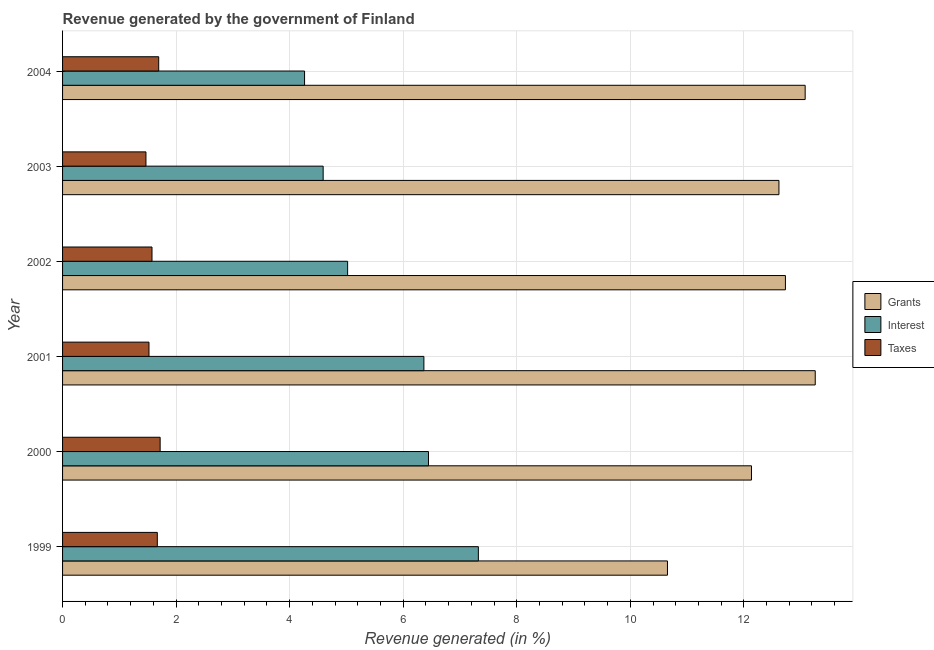How many groups of bars are there?
Make the answer very short. 6. How many bars are there on the 4th tick from the top?
Your response must be concise. 3. How many bars are there on the 1st tick from the bottom?
Provide a short and direct response. 3. In how many cases, is the number of bars for a given year not equal to the number of legend labels?
Ensure brevity in your answer.  0. What is the percentage of revenue generated by interest in 2003?
Ensure brevity in your answer.  4.59. Across all years, what is the maximum percentage of revenue generated by grants?
Keep it short and to the point. 13.26. Across all years, what is the minimum percentage of revenue generated by grants?
Your response must be concise. 10.65. In which year was the percentage of revenue generated by interest maximum?
Your response must be concise. 1999. What is the total percentage of revenue generated by interest in the graph?
Give a very brief answer. 34.01. What is the difference between the percentage of revenue generated by taxes in 2003 and that in 2004?
Your answer should be very brief. -0.23. What is the difference between the percentage of revenue generated by grants in 2001 and the percentage of revenue generated by interest in 2003?
Provide a succinct answer. 8.67. What is the average percentage of revenue generated by taxes per year?
Make the answer very short. 1.61. In the year 2003, what is the difference between the percentage of revenue generated by grants and percentage of revenue generated by taxes?
Provide a short and direct response. 11.15. In how many years, is the percentage of revenue generated by taxes greater than 10.4 %?
Your response must be concise. 0. What is the ratio of the percentage of revenue generated by interest in 2002 to that in 2004?
Your answer should be very brief. 1.18. Is the percentage of revenue generated by grants in 2000 less than that in 2001?
Your response must be concise. Yes. Is the difference between the percentage of revenue generated by taxes in 2000 and 2004 greater than the difference between the percentage of revenue generated by grants in 2000 and 2004?
Provide a short and direct response. Yes. What is the difference between the highest and the second highest percentage of revenue generated by interest?
Make the answer very short. 0.88. In how many years, is the percentage of revenue generated by interest greater than the average percentage of revenue generated by interest taken over all years?
Give a very brief answer. 3. What does the 1st bar from the top in 2000 represents?
Keep it short and to the point. Taxes. What does the 1st bar from the bottom in 2001 represents?
Give a very brief answer. Grants. How many years are there in the graph?
Your response must be concise. 6. Are the values on the major ticks of X-axis written in scientific E-notation?
Provide a succinct answer. No. Does the graph contain grids?
Provide a succinct answer. Yes. Where does the legend appear in the graph?
Ensure brevity in your answer.  Center right. How many legend labels are there?
Offer a very short reply. 3. What is the title of the graph?
Offer a terse response. Revenue generated by the government of Finland. What is the label or title of the X-axis?
Offer a very short reply. Revenue generated (in %). What is the label or title of the Y-axis?
Offer a terse response. Year. What is the Revenue generated (in %) of Grants in 1999?
Ensure brevity in your answer.  10.65. What is the Revenue generated (in %) in Interest in 1999?
Your response must be concise. 7.32. What is the Revenue generated (in %) of Taxes in 1999?
Ensure brevity in your answer.  1.67. What is the Revenue generated (in %) of Grants in 2000?
Your answer should be compact. 12.13. What is the Revenue generated (in %) in Interest in 2000?
Offer a terse response. 6.45. What is the Revenue generated (in %) in Taxes in 2000?
Offer a terse response. 1.72. What is the Revenue generated (in %) in Grants in 2001?
Offer a very short reply. 13.26. What is the Revenue generated (in %) of Interest in 2001?
Offer a very short reply. 6.36. What is the Revenue generated (in %) of Taxes in 2001?
Give a very brief answer. 1.52. What is the Revenue generated (in %) in Grants in 2002?
Provide a short and direct response. 12.73. What is the Revenue generated (in %) of Interest in 2002?
Your answer should be very brief. 5.02. What is the Revenue generated (in %) in Taxes in 2002?
Your answer should be compact. 1.58. What is the Revenue generated (in %) of Grants in 2003?
Make the answer very short. 12.62. What is the Revenue generated (in %) of Interest in 2003?
Give a very brief answer. 4.59. What is the Revenue generated (in %) of Taxes in 2003?
Offer a terse response. 1.47. What is the Revenue generated (in %) in Grants in 2004?
Provide a succinct answer. 13.08. What is the Revenue generated (in %) in Interest in 2004?
Your response must be concise. 4.26. What is the Revenue generated (in %) in Taxes in 2004?
Your response must be concise. 1.69. Across all years, what is the maximum Revenue generated (in %) in Grants?
Give a very brief answer. 13.26. Across all years, what is the maximum Revenue generated (in %) of Interest?
Offer a very short reply. 7.32. Across all years, what is the maximum Revenue generated (in %) in Taxes?
Your response must be concise. 1.72. Across all years, what is the minimum Revenue generated (in %) of Grants?
Ensure brevity in your answer.  10.65. Across all years, what is the minimum Revenue generated (in %) of Interest?
Provide a short and direct response. 4.26. Across all years, what is the minimum Revenue generated (in %) in Taxes?
Offer a very short reply. 1.47. What is the total Revenue generated (in %) in Grants in the graph?
Your answer should be compact. 74.48. What is the total Revenue generated (in %) of Interest in the graph?
Keep it short and to the point. 34.01. What is the total Revenue generated (in %) in Taxes in the graph?
Provide a short and direct response. 9.65. What is the difference between the Revenue generated (in %) in Grants in 1999 and that in 2000?
Offer a terse response. -1.48. What is the difference between the Revenue generated (in %) in Interest in 1999 and that in 2000?
Make the answer very short. 0.88. What is the difference between the Revenue generated (in %) of Taxes in 1999 and that in 2000?
Your answer should be compact. -0.05. What is the difference between the Revenue generated (in %) of Grants in 1999 and that in 2001?
Ensure brevity in your answer.  -2.6. What is the difference between the Revenue generated (in %) of Interest in 1999 and that in 2001?
Ensure brevity in your answer.  0.96. What is the difference between the Revenue generated (in %) in Taxes in 1999 and that in 2001?
Provide a succinct answer. 0.15. What is the difference between the Revenue generated (in %) of Grants in 1999 and that in 2002?
Keep it short and to the point. -2.08. What is the difference between the Revenue generated (in %) of Interest in 1999 and that in 2002?
Offer a very short reply. 2.3. What is the difference between the Revenue generated (in %) of Taxes in 1999 and that in 2002?
Offer a very short reply. 0.09. What is the difference between the Revenue generated (in %) in Grants in 1999 and that in 2003?
Offer a very short reply. -1.96. What is the difference between the Revenue generated (in %) in Interest in 1999 and that in 2003?
Your response must be concise. 2.73. What is the difference between the Revenue generated (in %) in Taxes in 1999 and that in 2003?
Provide a short and direct response. 0.2. What is the difference between the Revenue generated (in %) in Grants in 1999 and that in 2004?
Your answer should be very brief. -2.43. What is the difference between the Revenue generated (in %) of Interest in 1999 and that in 2004?
Your answer should be compact. 3.06. What is the difference between the Revenue generated (in %) in Taxes in 1999 and that in 2004?
Your response must be concise. -0.02. What is the difference between the Revenue generated (in %) of Grants in 2000 and that in 2001?
Keep it short and to the point. -1.12. What is the difference between the Revenue generated (in %) of Interest in 2000 and that in 2001?
Keep it short and to the point. 0.08. What is the difference between the Revenue generated (in %) of Taxes in 2000 and that in 2001?
Offer a very short reply. 0.2. What is the difference between the Revenue generated (in %) of Grants in 2000 and that in 2002?
Ensure brevity in your answer.  -0.6. What is the difference between the Revenue generated (in %) in Interest in 2000 and that in 2002?
Ensure brevity in your answer.  1.42. What is the difference between the Revenue generated (in %) in Taxes in 2000 and that in 2002?
Give a very brief answer. 0.14. What is the difference between the Revenue generated (in %) of Grants in 2000 and that in 2003?
Ensure brevity in your answer.  -0.48. What is the difference between the Revenue generated (in %) of Interest in 2000 and that in 2003?
Your answer should be compact. 1.86. What is the difference between the Revenue generated (in %) in Taxes in 2000 and that in 2003?
Your answer should be very brief. 0.25. What is the difference between the Revenue generated (in %) of Grants in 2000 and that in 2004?
Your response must be concise. -0.95. What is the difference between the Revenue generated (in %) in Interest in 2000 and that in 2004?
Offer a terse response. 2.18. What is the difference between the Revenue generated (in %) in Taxes in 2000 and that in 2004?
Provide a succinct answer. 0.03. What is the difference between the Revenue generated (in %) in Grants in 2001 and that in 2002?
Offer a terse response. 0.53. What is the difference between the Revenue generated (in %) of Interest in 2001 and that in 2002?
Ensure brevity in your answer.  1.34. What is the difference between the Revenue generated (in %) in Taxes in 2001 and that in 2002?
Keep it short and to the point. -0.05. What is the difference between the Revenue generated (in %) in Grants in 2001 and that in 2003?
Your answer should be compact. 0.64. What is the difference between the Revenue generated (in %) of Interest in 2001 and that in 2003?
Offer a terse response. 1.77. What is the difference between the Revenue generated (in %) of Taxes in 2001 and that in 2003?
Provide a succinct answer. 0.05. What is the difference between the Revenue generated (in %) in Grants in 2001 and that in 2004?
Make the answer very short. 0.18. What is the difference between the Revenue generated (in %) in Interest in 2001 and that in 2004?
Your response must be concise. 2.1. What is the difference between the Revenue generated (in %) of Taxes in 2001 and that in 2004?
Provide a short and direct response. -0.17. What is the difference between the Revenue generated (in %) in Grants in 2002 and that in 2003?
Your answer should be very brief. 0.11. What is the difference between the Revenue generated (in %) in Interest in 2002 and that in 2003?
Keep it short and to the point. 0.43. What is the difference between the Revenue generated (in %) in Taxes in 2002 and that in 2003?
Give a very brief answer. 0.11. What is the difference between the Revenue generated (in %) in Grants in 2002 and that in 2004?
Offer a terse response. -0.35. What is the difference between the Revenue generated (in %) in Interest in 2002 and that in 2004?
Your response must be concise. 0.76. What is the difference between the Revenue generated (in %) in Taxes in 2002 and that in 2004?
Provide a succinct answer. -0.12. What is the difference between the Revenue generated (in %) in Grants in 2003 and that in 2004?
Your answer should be compact. -0.46. What is the difference between the Revenue generated (in %) of Interest in 2003 and that in 2004?
Offer a terse response. 0.33. What is the difference between the Revenue generated (in %) of Taxes in 2003 and that in 2004?
Keep it short and to the point. -0.22. What is the difference between the Revenue generated (in %) of Grants in 1999 and the Revenue generated (in %) of Interest in 2000?
Your answer should be very brief. 4.21. What is the difference between the Revenue generated (in %) of Grants in 1999 and the Revenue generated (in %) of Taxes in 2000?
Keep it short and to the point. 8.94. What is the difference between the Revenue generated (in %) of Interest in 1999 and the Revenue generated (in %) of Taxes in 2000?
Offer a terse response. 5.61. What is the difference between the Revenue generated (in %) in Grants in 1999 and the Revenue generated (in %) in Interest in 2001?
Offer a terse response. 4.29. What is the difference between the Revenue generated (in %) in Grants in 1999 and the Revenue generated (in %) in Taxes in 2001?
Offer a terse response. 9.13. What is the difference between the Revenue generated (in %) of Interest in 1999 and the Revenue generated (in %) of Taxes in 2001?
Offer a terse response. 5.8. What is the difference between the Revenue generated (in %) in Grants in 1999 and the Revenue generated (in %) in Interest in 2002?
Offer a very short reply. 5.63. What is the difference between the Revenue generated (in %) of Grants in 1999 and the Revenue generated (in %) of Taxes in 2002?
Ensure brevity in your answer.  9.08. What is the difference between the Revenue generated (in %) of Interest in 1999 and the Revenue generated (in %) of Taxes in 2002?
Keep it short and to the point. 5.75. What is the difference between the Revenue generated (in %) in Grants in 1999 and the Revenue generated (in %) in Interest in 2003?
Offer a very short reply. 6.06. What is the difference between the Revenue generated (in %) in Grants in 1999 and the Revenue generated (in %) in Taxes in 2003?
Your answer should be very brief. 9.19. What is the difference between the Revenue generated (in %) of Interest in 1999 and the Revenue generated (in %) of Taxes in 2003?
Ensure brevity in your answer.  5.86. What is the difference between the Revenue generated (in %) of Grants in 1999 and the Revenue generated (in %) of Interest in 2004?
Offer a terse response. 6.39. What is the difference between the Revenue generated (in %) of Grants in 1999 and the Revenue generated (in %) of Taxes in 2004?
Ensure brevity in your answer.  8.96. What is the difference between the Revenue generated (in %) in Interest in 1999 and the Revenue generated (in %) in Taxes in 2004?
Provide a short and direct response. 5.63. What is the difference between the Revenue generated (in %) in Grants in 2000 and the Revenue generated (in %) in Interest in 2001?
Offer a terse response. 5.77. What is the difference between the Revenue generated (in %) in Grants in 2000 and the Revenue generated (in %) in Taxes in 2001?
Provide a short and direct response. 10.61. What is the difference between the Revenue generated (in %) in Interest in 2000 and the Revenue generated (in %) in Taxes in 2001?
Keep it short and to the point. 4.92. What is the difference between the Revenue generated (in %) in Grants in 2000 and the Revenue generated (in %) in Interest in 2002?
Provide a succinct answer. 7.11. What is the difference between the Revenue generated (in %) in Grants in 2000 and the Revenue generated (in %) in Taxes in 2002?
Your response must be concise. 10.56. What is the difference between the Revenue generated (in %) of Interest in 2000 and the Revenue generated (in %) of Taxes in 2002?
Your answer should be compact. 4.87. What is the difference between the Revenue generated (in %) in Grants in 2000 and the Revenue generated (in %) in Interest in 2003?
Your answer should be compact. 7.54. What is the difference between the Revenue generated (in %) of Grants in 2000 and the Revenue generated (in %) of Taxes in 2003?
Your answer should be compact. 10.67. What is the difference between the Revenue generated (in %) of Interest in 2000 and the Revenue generated (in %) of Taxes in 2003?
Your answer should be very brief. 4.98. What is the difference between the Revenue generated (in %) of Grants in 2000 and the Revenue generated (in %) of Interest in 2004?
Keep it short and to the point. 7.87. What is the difference between the Revenue generated (in %) in Grants in 2000 and the Revenue generated (in %) in Taxes in 2004?
Your answer should be very brief. 10.44. What is the difference between the Revenue generated (in %) in Interest in 2000 and the Revenue generated (in %) in Taxes in 2004?
Provide a short and direct response. 4.75. What is the difference between the Revenue generated (in %) in Grants in 2001 and the Revenue generated (in %) in Interest in 2002?
Offer a terse response. 8.24. What is the difference between the Revenue generated (in %) in Grants in 2001 and the Revenue generated (in %) in Taxes in 2002?
Keep it short and to the point. 11.68. What is the difference between the Revenue generated (in %) in Interest in 2001 and the Revenue generated (in %) in Taxes in 2002?
Your answer should be compact. 4.79. What is the difference between the Revenue generated (in %) of Grants in 2001 and the Revenue generated (in %) of Interest in 2003?
Keep it short and to the point. 8.67. What is the difference between the Revenue generated (in %) of Grants in 2001 and the Revenue generated (in %) of Taxes in 2003?
Offer a very short reply. 11.79. What is the difference between the Revenue generated (in %) in Interest in 2001 and the Revenue generated (in %) in Taxes in 2003?
Your response must be concise. 4.9. What is the difference between the Revenue generated (in %) of Grants in 2001 and the Revenue generated (in %) of Interest in 2004?
Offer a terse response. 9. What is the difference between the Revenue generated (in %) in Grants in 2001 and the Revenue generated (in %) in Taxes in 2004?
Make the answer very short. 11.56. What is the difference between the Revenue generated (in %) of Interest in 2001 and the Revenue generated (in %) of Taxes in 2004?
Provide a short and direct response. 4.67. What is the difference between the Revenue generated (in %) in Grants in 2002 and the Revenue generated (in %) in Interest in 2003?
Ensure brevity in your answer.  8.14. What is the difference between the Revenue generated (in %) of Grants in 2002 and the Revenue generated (in %) of Taxes in 2003?
Offer a terse response. 11.26. What is the difference between the Revenue generated (in %) of Interest in 2002 and the Revenue generated (in %) of Taxes in 2003?
Your response must be concise. 3.55. What is the difference between the Revenue generated (in %) of Grants in 2002 and the Revenue generated (in %) of Interest in 2004?
Your answer should be compact. 8.47. What is the difference between the Revenue generated (in %) of Grants in 2002 and the Revenue generated (in %) of Taxes in 2004?
Offer a terse response. 11.04. What is the difference between the Revenue generated (in %) of Interest in 2002 and the Revenue generated (in %) of Taxes in 2004?
Keep it short and to the point. 3.33. What is the difference between the Revenue generated (in %) of Grants in 2003 and the Revenue generated (in %) of Interest in 2004?
Your response must be concise. 8.36. What is the difference between the Revenue generated (in %) of Grants in 2003 and the Revenue generated (in %) of Taxes in 2004?
Make the answer very short. 10.93. What is the difference between the Revenue generated (in %) of Interest in 2003 and the Revenue generated (in %) of Taxes in 2004?
Your answer should be very brief. 2.9. What is the average Revenue generated (in %) of Grants per year?
Make the answer very short. 12.41. What is the average Revenue generated (in %) in Interest per year?
Your answer should be compact. 5.67. What is the average Revenue generated (in %) in Taxes per year?
Provide a succinct answer. 1.61. In the year 1999, what is the difference between the Revenue generated (in %) of Grants and Revenue generated (in %) of Interest?
Your response must be concise. 3.33. In the year 1999, what is the difference between the Revenue generated (in %) in Grants and Revenue generated (in %) in Taxes?
Keep it short and to the point. 8.99. In the year 1999, what is the difference between the Revenue generated (in %) in Interest and Revenue generated (in %) in Taxes?
Ensure brevity in your answer.  5.66. In the year 2000, what is the difference between the Revenue generated (in %) of Grants and Revenue generated (in %) of Interest?
Your answer should be very brief. 5.69. In the year 2000, what is the difference between the Revenue generated (in %) of Grants and Revenue generated (in %) of Taxes?
Keep it short and to the point. 10.42. In the year 2000, what is the difference between the Revenue generated (in %) of Interest and Revenue generated (in %) of Taxes?
Provide a short and direct response. 4.73. In the year 2001, what is the difference between the Revenue generated (in %) of Grants and Revenue generated (in %) of Interest?
Your response must be concise. 6.89. In the year 2001, what is the difference between the Revenue generated (in %) of Grants and Revenue generated (in %) of Taxes?
Your answer should be very brief. 11.74. In the year 2001, what is the difference between the Revenue generated (in %) of Interest and Revenue generated (in %) of Taxes?
Give a very brief answer. 4.84. In the year 2002, what is the difference between the Revenue generated (in %) of Grants and Revenue generated (in %) of Interest?
Your response must be concise. 7.71. In the year 2002, what is the difference between the Revenue generated (in %) in Grants and Revenue generated (in %) in Taxes?
Make the answer very short. 11.16. In the year 2002, what is the difference between the Revenue generated (in %) of Interest and Revenue generated (in %) of Taxes?
Provide a succinct answer. 3.45. In the year 2003, what is the difference between the Revenue generated (in %) in Grants and Revenue generated (in %) in Interest?
Provide a short and direct response. 8.03. In the year 2003, what is the difference between the Revenue generated (in %) of Grants and Revenue generated (in %) of Taxes?
Give a very brief answer. 11.15. In the year 2003, what is the difference between the Revenue generated (in %) of Interest and Revenue generated (in %) of Taxes?
Provide a short and direct response. 3.12. In the year 2004, what is the difference between the Revenue generated (in %) in Grants and Revenue generated (in %) in Interest?
Make the answer very short. 8.82. In the year 2004, what is the difference between the Revenue generated (in %) in Grants and Revenue generated (in %) in Taxes?
Offer a very short reply. 11.39. In the year 2004, what is the difference between the Revenue generated (in %) of Interest and Revenue generated (in %) of Taxes?
Your answer should be very brief. 2.57. What is the ratio of the Revenue generated (in %) in Grants in 1999 to that in 2000?
Your response must be concise. 0.88. What is the ratio of the Revenue generated (in %) of Interest in 1999 to that in 2000?
Offer a terse response. 1.14. What is the ratio of the Revenue generated (in %) in Taxes in 1999 to that in 2000?
Provide a short and direct response. 0.97. What is the ratio of the Revenue generated (in %) in Grants in 1999 to that in 2001?
Your answer should be very brief. 0.8. What is the ratio of the Revenue generated (in %) in Interest in 1999 to that in 2001?
Provide a succinct answer. 1.15. What is the ratio of the Revenue generated (in %) of Taxes in 1999 to that in 2001?
Offer a terse response. 1.1. What is the ratio of the Revenue generated (in %) in Grants in 1999 to that in 2002?
Ensure brevity in your answer.  0.84. What is the ratio of the Revenue generated (in %) of Interest in 1999 to that in 2002?
Make the answer very short. 1.46. What is the ratio of the Revenue generated (in %) in Taxes in 1999 to that in 2002?
Provide a short and direct response. 1.06. What is the ratio of the Revenue generated (in %) of Grants in 1999 to that in 2003?
Your answer should be compact. 0.84. What is the ratio of the Revenue generated (in %) of Interest in 1999 to that in 2003?
Give a very brief answer. 1.6. What is the ratio of the Revenue generated (in %) in Taxes in 1999 to that in 2003?
Provide a short and direct response. 1.14. What is the ratio of the Revenue generated (in %) of Grants in 1999 to that in 2004?
Provide a short and direct response. 0.81. What is the ratio of the Revenue generated (in %) of Interest in 1999 to that in 2004?
Give a very brief answer. 1.72. What is the ratio of the Revenue generated (in %) in Taxes in 1999 to that in 2004?
Provide a short and direct response. 0.99. What is the ratio of the Revenue generated (in %) in Grants in 2000 to that in 2001?
Your answer should be compact. 0.92. What is the ratio of the Revenue generated (in %) in Interest in 2000 to that in 2001?
Provide a short and direct response. 1.01. What is the ratio of the Revenue generated (in %) of Taxes in 2000 to that in 2001?
Your answer should be very brief. 1.13. What is the ratio of the Revenue generated (in %) in Grants in 2000 to that in 2002?
Your answer should be compact. 0.95. What is the ratio of the Revenue generated (in %) in Interest in 2000 to that in 2002?
Provide a succinct answer. 1.28. What is the ratio of the Revenue generated (in %) in Taxes in 2000 to that in 2002?
Your answer should be very brief. 1.09. What is the ratio of the Revenue generated (in %) of Grants in 2000 to that in 2003?
Provide a short and direct response. 0.96. What is the ratio of the Revenue generated (in %) of Interest in 2000 to that in 2003?
Offer a terse response. 1.4. What is the ratio of the Revenue generated (in %) in Taxes in 2000 to that in 2003?
Give a very brief answer. 1.17. What is the ratio of the Revenue generated (in %) in Grants in 2000 to that in 2004?
Your response must be concise. 0.93. What is the ratio of the Revenue generated (in %) of Interest in 2000 to that in 2004?
Provide a short and direct response. 1.51. What is the ratio of the Revenue generated (in %) in Taxes in 2000 to that in 2004?
Ensure brevity in your answer.  1.01. What is the ratio of the Revenue generated (in %) of Grants in 2001 to that in 2002?
Your response must be concise. 1.04. What is the ratio of the Revenue generated (in %) in Interest in 2001 to that in 2002?
Offer a very short reply. 1.27. What is the ratio of the Revenue generated (in %) of Taxes in 2001 to that in 2002?
Make the answer very short. 0.97. What is the ratio of the Revenue generated (in %) of Grants in 2001 to that in 2003?
Your answer should be compact. 1.05. What is the ratio of the Revenue generated (in %) of Interest in 2001 to that in 2003?
Make the answer very short. 1.39. What is the ratio of the Revenue generated (in %) of Taxes in 2001 to that in 2003?
Your response must be concise. 1.04. What is the ratio of the Revenue generated (in %) in Grants in 2001 to that in 2004?
Keep it short and to the point. 1.01. What is the ratio of the Revenue generated (in %) of Interest in 2001 to that in 2004?
Your response must be concise. 1.49. What is the ratio of the Revenue generated (in %) of Taxes in 2001 to that in 2004?
Your answer should be compact. 0.9. What is the ratio of the Revenue generated (in %) of Grants in 2002 to that in 2003?
Ensure brevity in your answer.  1.01. What is the ratio of the Revenue generated (in %) in Interest in 2002 to that in 2003?
Offer a very short reply. 1.09. What is the ratio of the Revenue generated (in %) of Taxes in 2002 to that in 2003?
Offer a very short reply. 1.07. What is the ratio of the Revenue generated (in %) of Grants in 2002 to that in 2004?
Provide a succinct answer. 0.97. What is the ratio of the Revenue generated (in %) of Interest in 2002 to that in 2004?
Provide a short and direct response. 1.18. What is the ratio of the Revenue generated (in %) in Taxes in 2002 to that in 2004?
Your answer should be compact. 0.93. What is the ratio of the Revenue generated (in %) of Grants in 2003 to that in 2004?
Ensure brevity in your answer.  0.96. What is the ratio of the Revenue generated (in %) in Interest in 2003 to that in 2004?
Your answer should be very brief. 1.08. What is the ratio of the Revenue generated (in %) in Taxes in 2003 to that in 2004?
Your answer should be very brief. 0.87. What is the difference between the highest and the second highest Revenue generated (in %) of Grants?
Your response must be concise. 0.18. What is the difference between the highest and the second highest Revenue generated (in %) in Interest?
Offer a terse response. 0.88. What is the difference between the highest and the second highest Revenue generated (in %) in Taxes?
Keep it short and to the point. 0.03. What is the difference between the highest and the lowest Revenue generated (in %) of Grants?
Your answer should be compact. 2.6. What is the difference between the highest and the lowest Revenue generated (in %) in Interest?
Give a very brief answer. 3.06. What is the difference between the highest and the lowest Revenue generated (in %) of Taxes?
Give a very brief answer. 0.25. 